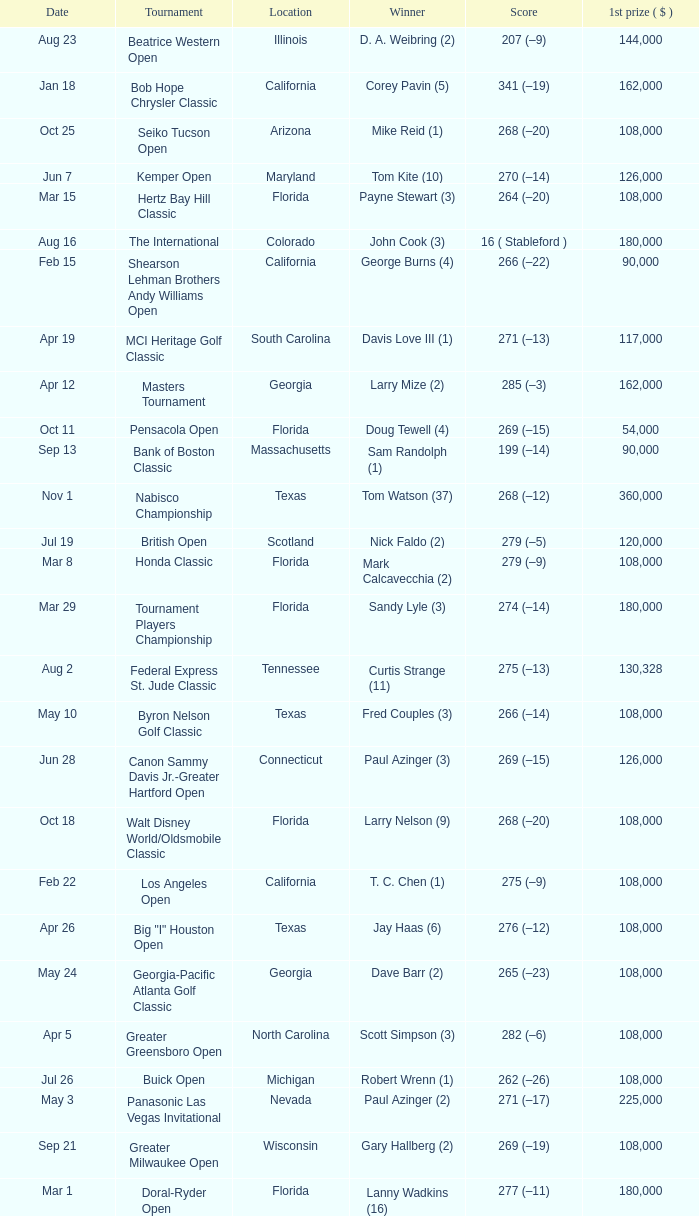What is the date where the winner was Tom Kite (10)? Jun 7. 